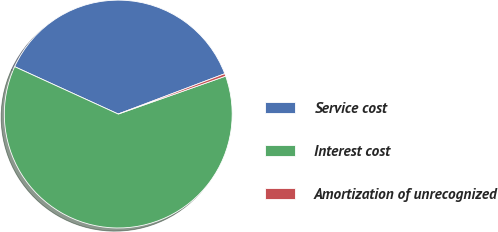Convert chart to OTSL. <chart><loc_0><loc_0><loc_500><loc_500><pie_chart><fcel>Service cost<fcel>Interest cost<fcel>Amortization of unrecognized<nl><fcel>37.41%<fcel>62.23%<fcel>0.36%<nl></chart> 